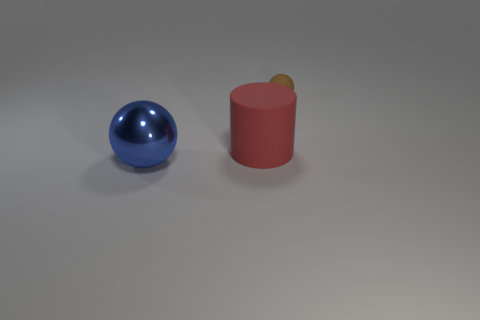The matte cylinder that is the same size as the metal sphere is what color? The matte cylinder, seen in the image as being comparable in size to the metallic sphere, exhibits a reddish hue, more specifically a deep salmon color. This observation accounts for the lighting and shading visible in the image that can affect the perception of color. 